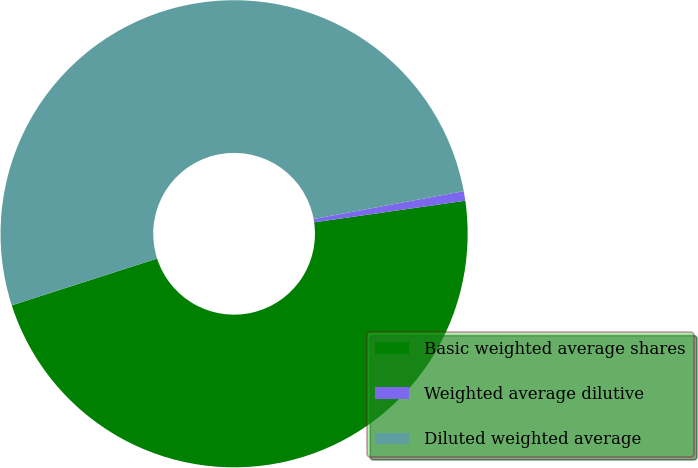Convert chart. <chart><loc_0><loc_0><loc_500><loc_500><pie_chart><fcel>Basic weighted average shares<fcel>Weighted average dilutive<fcel>Diluted weighted average<nl><fcel>47.31%<fcel>0.66%<fcel>52.04%<nl></chart> 